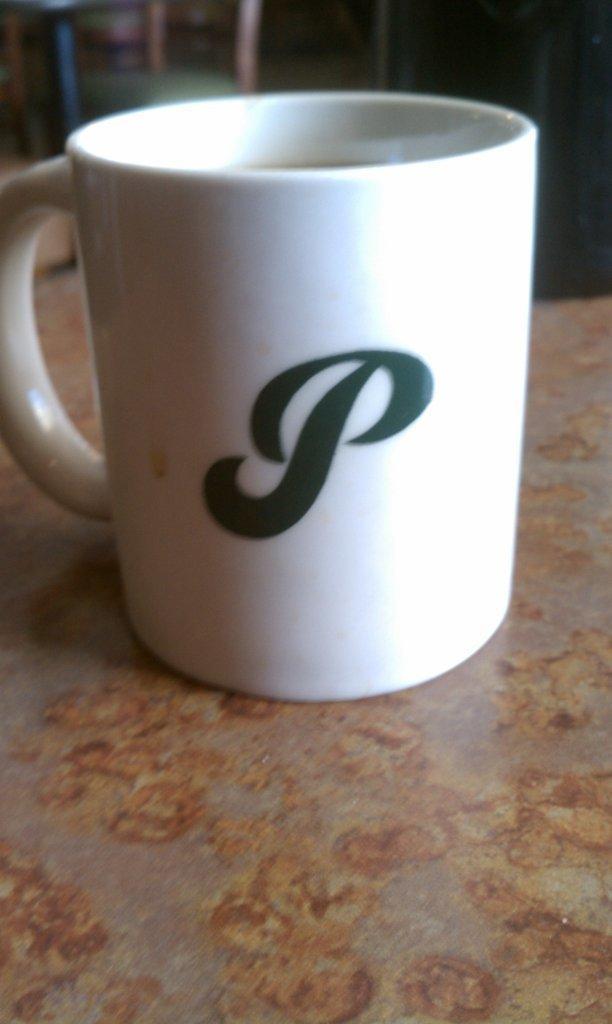Could you give a brief overview of what you see in this image? As we can see in the image there is a table. On table there is a white color cup. In the background there is a chair. 